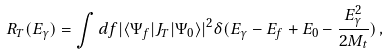Convert formula to latex. <formula><loc_0><loc_0><loc_500><loc_500>R _ { T } ( E _ { \gamma } ) = \int d f | \langle \Psi _ { f } | { J _ { T } } | \Psi _ { 0 } \rangle | ^ { 2 } \delta ( E _ { \gamma } - E _ { f } + E _ { 0 } - \frac { E _ { \gamma } ^ { 2 } } { 2 M _ { t } } ) \, ,</formula> 